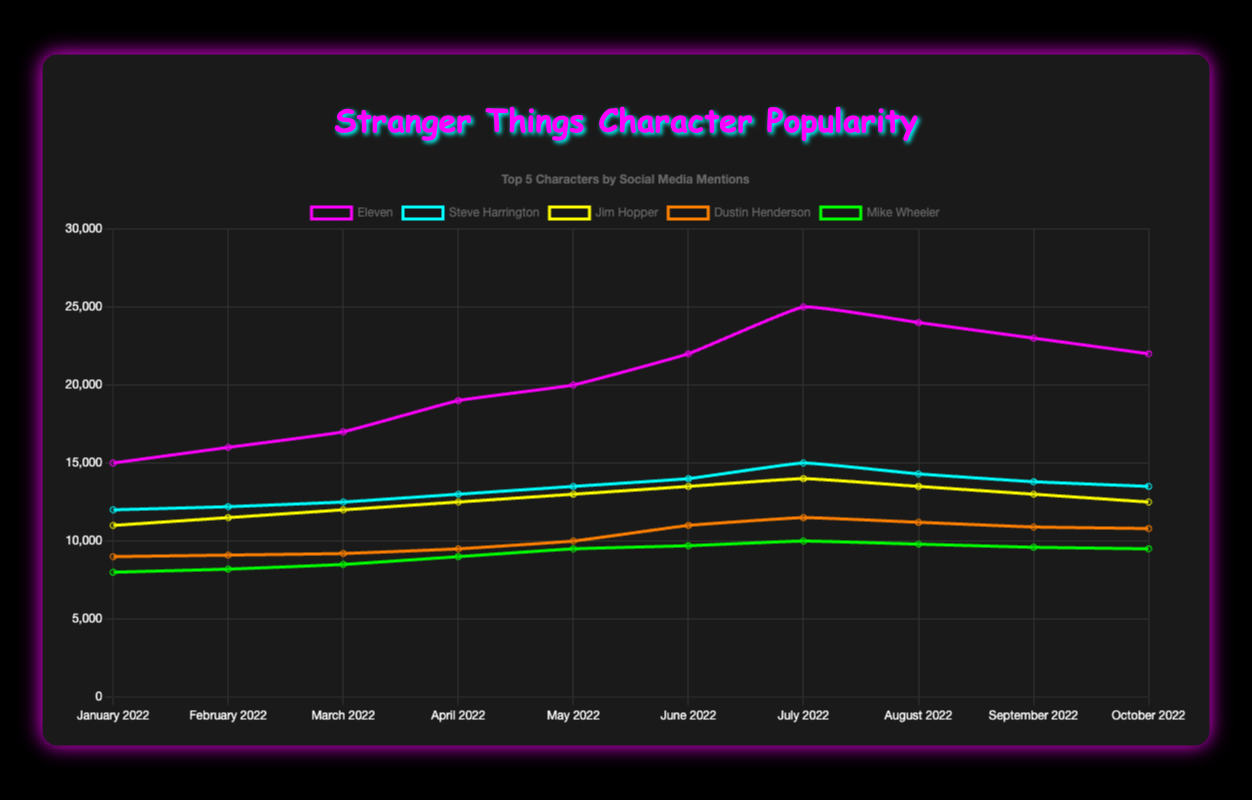Which character experienced the biggest increase in social media mentions from January 2022 to July 2022? To find the character with the biggest increase, look at the difference in mentions for each character between January and July. Eleven increases from 15,000 to 25,000 (an increase of 10,000), while other characters have smaller increases.
Answer: Eleven Between which two months did Steve Harrington's popularity increase the most? To find the biggest increase, look at the mentions for Steve Harrington in consecutive months. The biggest increase is from June (14,000) to July (15,000), which is an increase of 1,000.
Answer: June to July What is the average number of mentions for Jim Hopper across the entire time period? Add up all mentions for Jim Hopper and divide by the number of months. The total is (11,000 + 11,500 + 12,000 + 12,500 + 13,000 + 13,500 + 14,000 + 13,500 + 13,000 + 12,500) = 127,500, and there are 10 months, so the average is 127,500 / 10 = 12,750.
Answer: 12,750 Which month saw the highest overall mentions for the top 5 characters combined? Sum the mentions for the top 5 characters for each month and find the month with the highest sum. July has the highest combined mentions: Eleven (25,000) + Steve Harrington (15,000) + Jim Hopper (14,000) + Dustin Henderson (11,500) + Mike Wheeler (10,000) = 75,500.
Answer: July How many more mentions did Eleven have in August 2022 compared to Max Mayfield in the same month? Subtract Max Mayfield's mentions from Eleven's mentions in August. Eleven had 24,000, while Max Mayfield had 6,200, so the difference is 24,000 - 6,200 = 17,800.
Answer: 17,800 By how much did Robin Buckley's mentions increase from January to June 2022? Subtract Robin Buckley's mentions in January from her mentions in June. In June, she had 5,500 mentions, and in January, she had 4,000, so the increase is 5,500 - 4,000 = 1,500.
Answer: 1,500 Which two characters have the closest mention counts in October 2022? Compare the mention counts for all characters in October. Joyce Byers (8,500) and Jim Hopper (12,500) are not the closest pair. The closest pair in October are Lucas Sinclair (7,500) and Nancy Wheeler (7,000), with a difference of 500.
Answer: Lucas Sinclair and Nancy Wheeler What is the median number of mentions for Max Mayfield over the 10 months? List all monthly mentions for Max Mayfield in ascending order: (5,000; 5,100; 5,300; 5,500; 5,700; 6,000; 6,200; 6,300; 6,100; 6,000). The median is the average of the 5th and 6th values: (5,700 + 6,000) / 2 = 5,850.
Answer: 5,850 